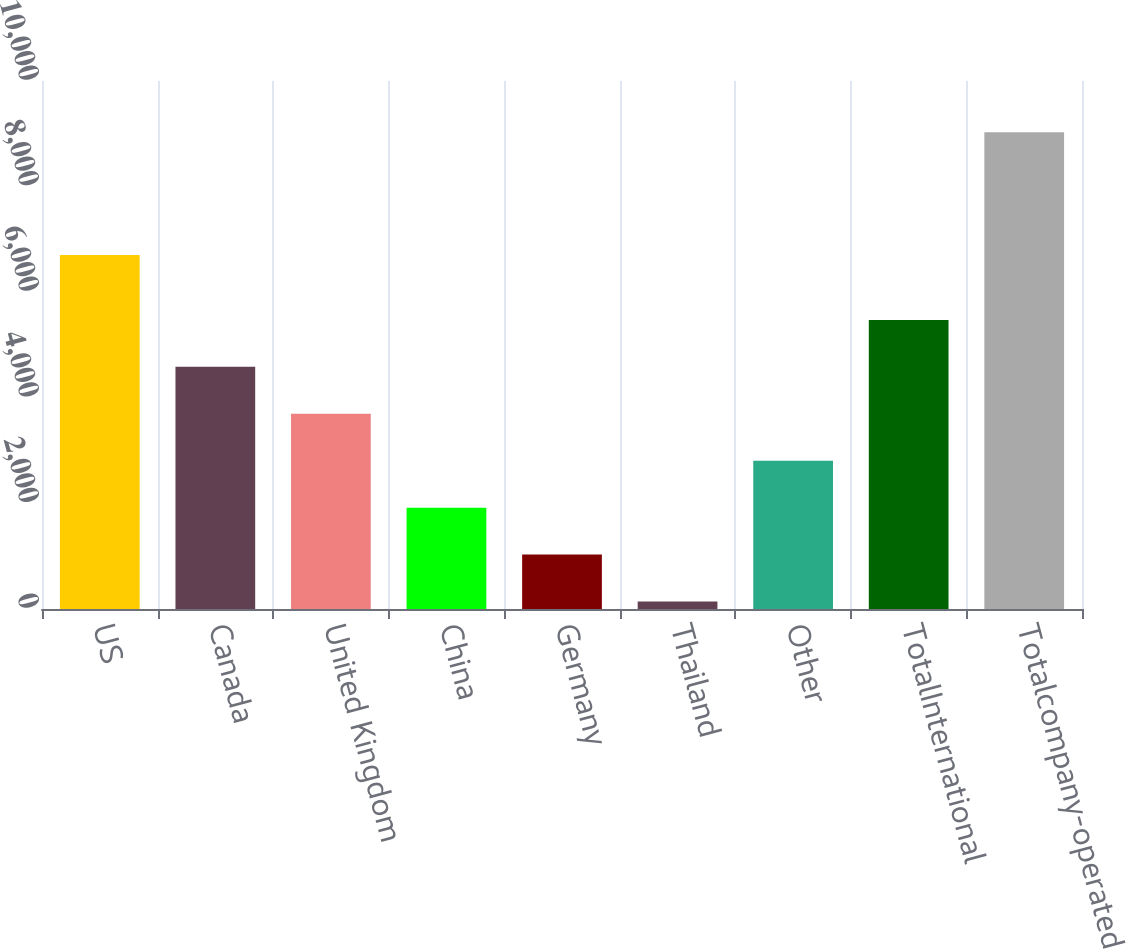Convert chart. <chart><loc_0><loc_0><loc_500><loc_500><bar_chart><fcel>US<fcel>Canada<fcel>United Kingdom<fcel>China<fcel>Germany<fcel>Thailand<fcel>Other<fcel>TotalInternational<fcel>Totalcompany-operated<nl><fcel>6705<fcel>4586<fcel>3697<fcel>1919<fcel>1030<fcel>141<fcel>2808<fcel>5475<fcel>9031<nl></chart> 